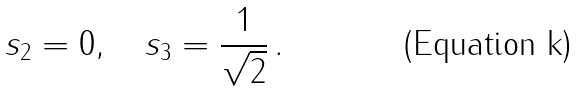<formula> <loc_0><loc_0><loc_500><loc_500>s _ { 2 } = 0 , \quad s _ { 3 } = \frac { 1 } { \sqrt { 2 } } \, .</formula> 